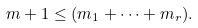Convert formula to latex. <formula><loc_0><loc_0><loc_500><loc_500>m + 1 \leq ( m _ { 1 } + \dots + m _ { r } ) .</formula> 